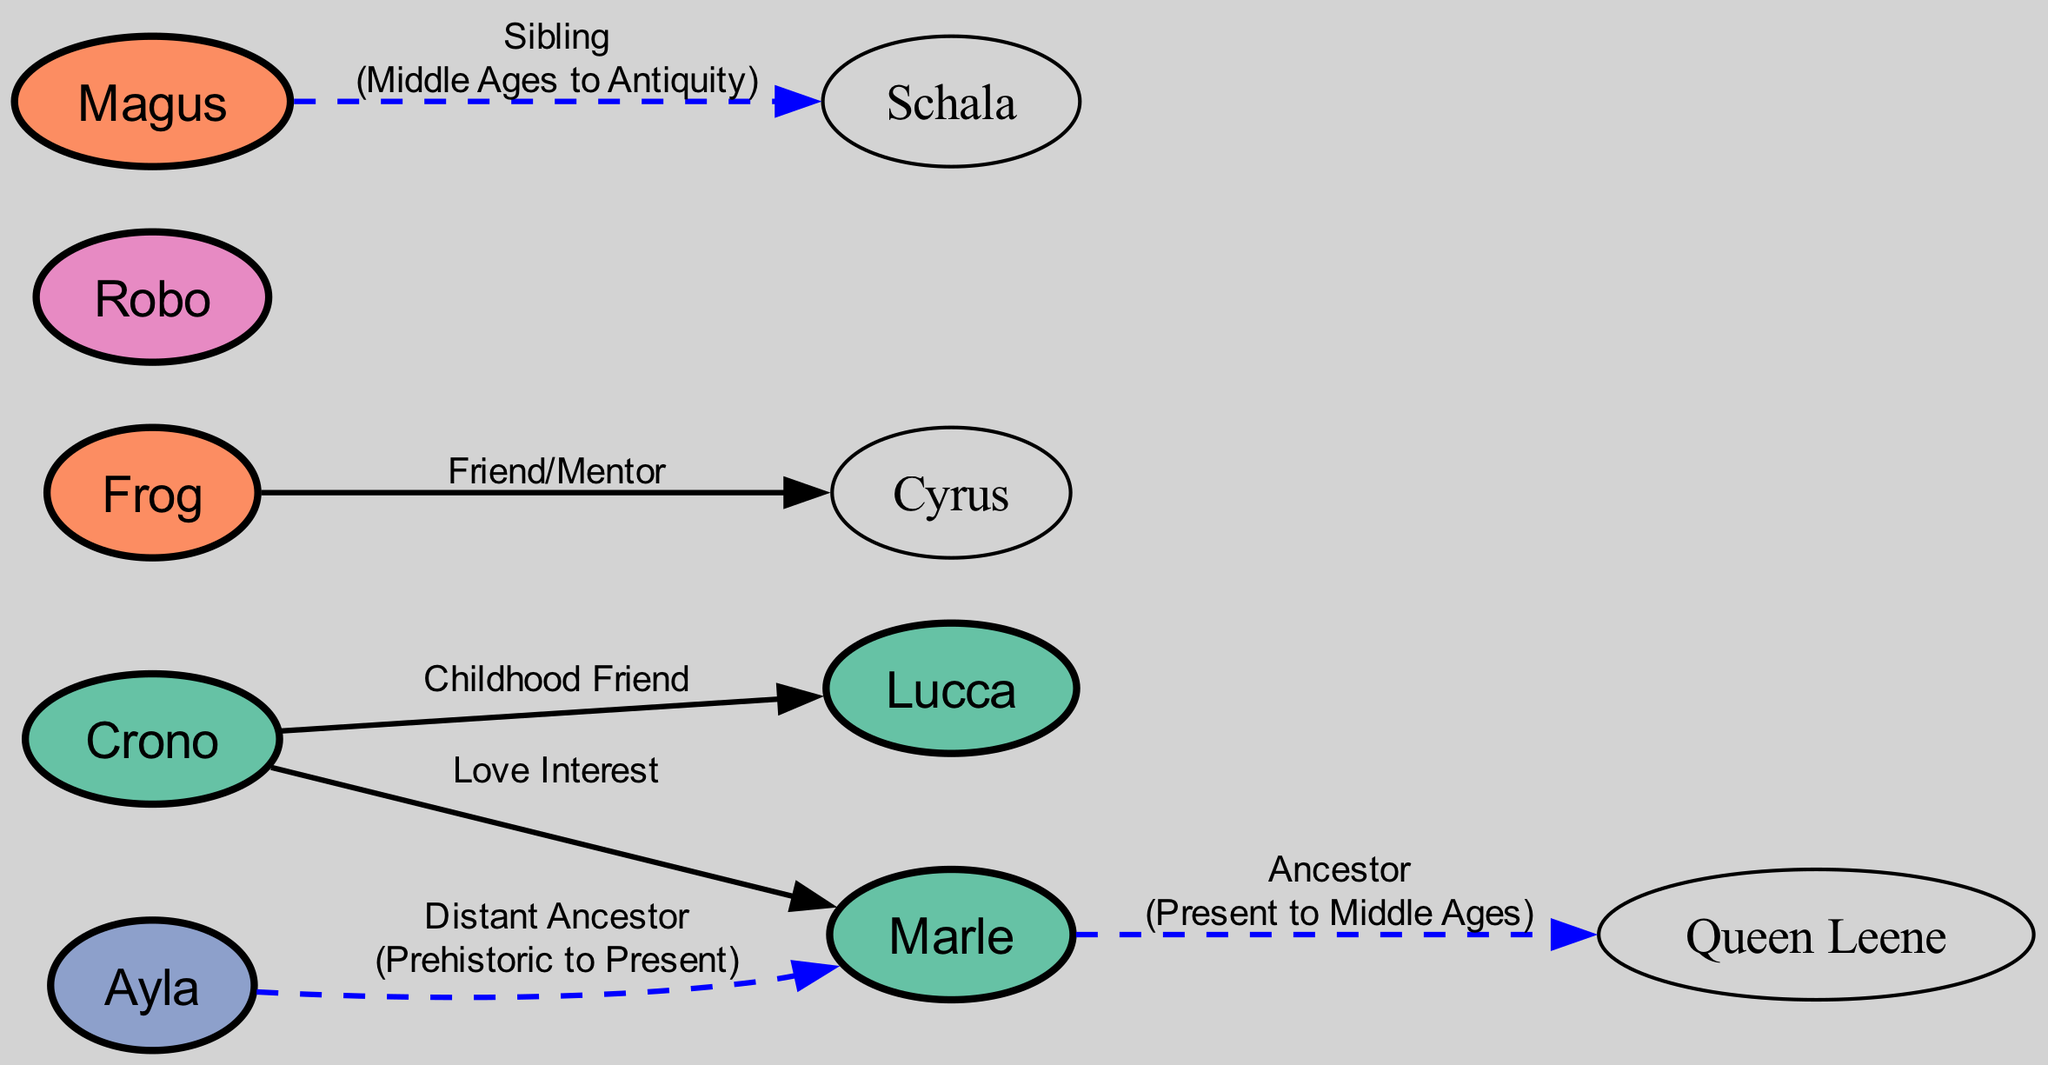What is the relationship type between Crono and Marle? The diagram shows a direct connection between Crono and Marle with the label "Love Interest". This indicates their romantic relationship.
Answer: Love Interest How many characters are from the Present era? By counting the nodes, we find Crono, Marle, and Lucca listed under the Present era, resulting in a total of three characters.
Answer: 3 Who is Ayla a distant ancestor to? The relationship line connects Ayla to Marle with the label "Distant Ancestor." This shows that Ayla is related to Marle across different time eras, specifically from Prehistoric to Present.
Answer: Marle What color represents the Future era in the diagram? The Future era is represented by a specific color in the diagram, which is shown to be light pink (#e78ac3).
Answer: Light pink How many relationships involve characters from the Middle Ages? The diagram indicates relationships for two characters from the Middle Ages: Frog and Magus. Frog's connection is to Cyrus, and Magus’s is to Schala, giving a total of two relationships.
Answer: 2 What is the type of relationship between Magus and Schala? The diagram shows a relationship label connecting Magus and Schala identified as "Sibling," indicating that they are brothers or sisters.
Answer: Sibling Which character has a childhood friend relationship with Crono? Looking at the relationships in the diagram, Lucca is labeled as Crono's "Childhood Friend," indicating their close friendship developed during their youth.
Answer: Lucca What is the era connection between Marle and Queen Leene? The diagram explicitly states that Marle is an ancestor of Queen Leene, with an era connection going from Present to Middle Ages, highlighting a timeframe between their generations.
Answer: Present to Middle Ages 